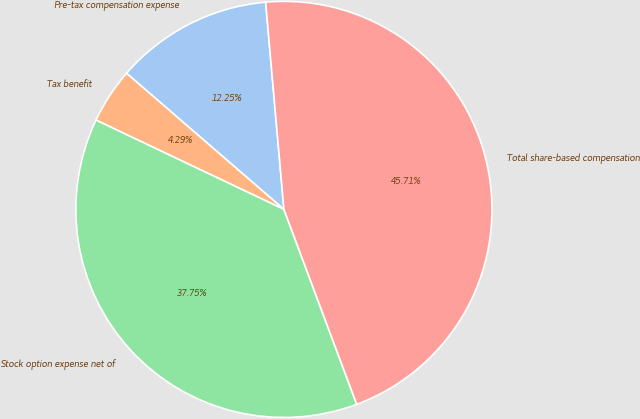<chart> <loc_0><loc_0><loc_500><loc_500><pie_chart><fcel>Pre-tax compensation expense<fcel>Tax benefit<fcel>Stock option expense net of<fcel>Total share-based compensation<nl><fcel>12.25%<fcel>4.29%<fcel>37.75%<fcel>45.71%<nl></chart> 